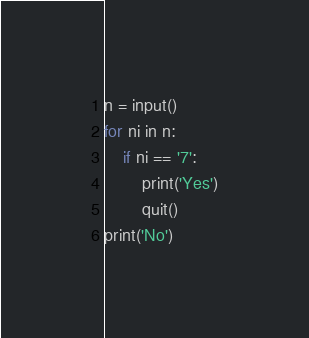Convert code to text. <code><loc_0><loc_0><loc_500><loc_500><_Python_>n = input()
for ni in n:
    if ni == '7':
        print('Yes')
        quit()
print('No')
</code> 